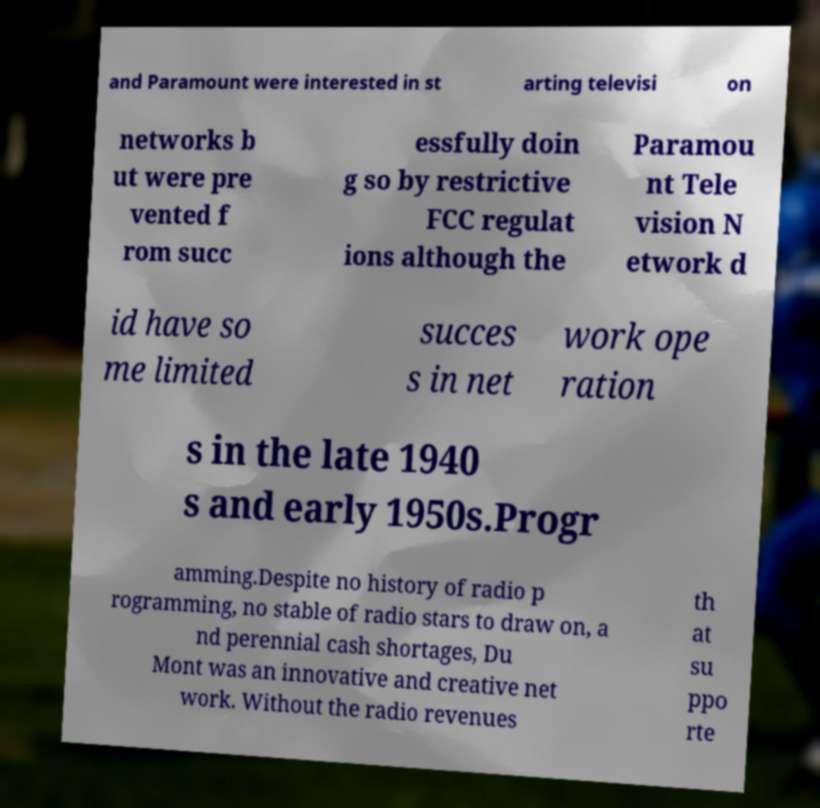Could you extract and type out the text from this image? and Paramount were interested in st arting televisi on networks b ut were pre vented f rom succ essfully doin g so by restrictive FCC regulat ions although the Paramou nt Tele vision N etwork d id have so me limited succes s in net work ope ration s in the late 1940 s and early 1950s.Progr amming.Despite no history of radio p rogramming, no stable of radio stars to draw on, a nd perennial cash shortages, Du Mont was an innovative and creative net work. Without the radio revenues th at su ppo rte 